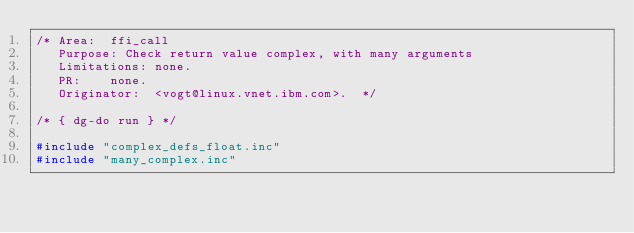<code> <loc_0><loc_0><loc_500><loc_500><_C_>/* Area:	ffi_call
   Purpose:	Check return value complex, with many arguments
   Limitations:	none.
   PR:		none.
   Originator:	<vogt@linux.vnet.ibm.com>.  */

/* { dg-do run } */

#include "complex_defs_float.inc"
#include "many_complex.inc"
</code> 